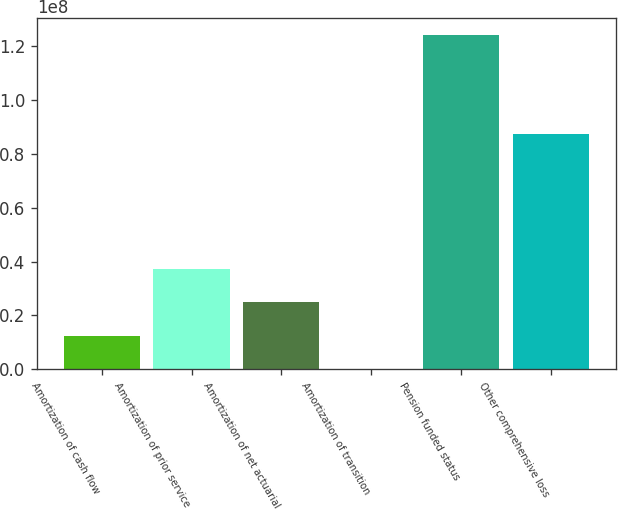<chart> <loc_0><loc_0><loc_500><loc_500><bar_chart><fcel>Amortization of cash flow<fcel>Amortization of prior service<fcel>Amortization of net actuarial<fcel>Amortization of transition<fcel>Pension funded status<fcel>Other comprehensive loss<nl><fcel>1.25138e+07<fcel>3.73554e+07<fcel>2.49346e+07<fcel>93000<fcel>1.24301e+08<fcel>8.7487e+07<nl></chart> 